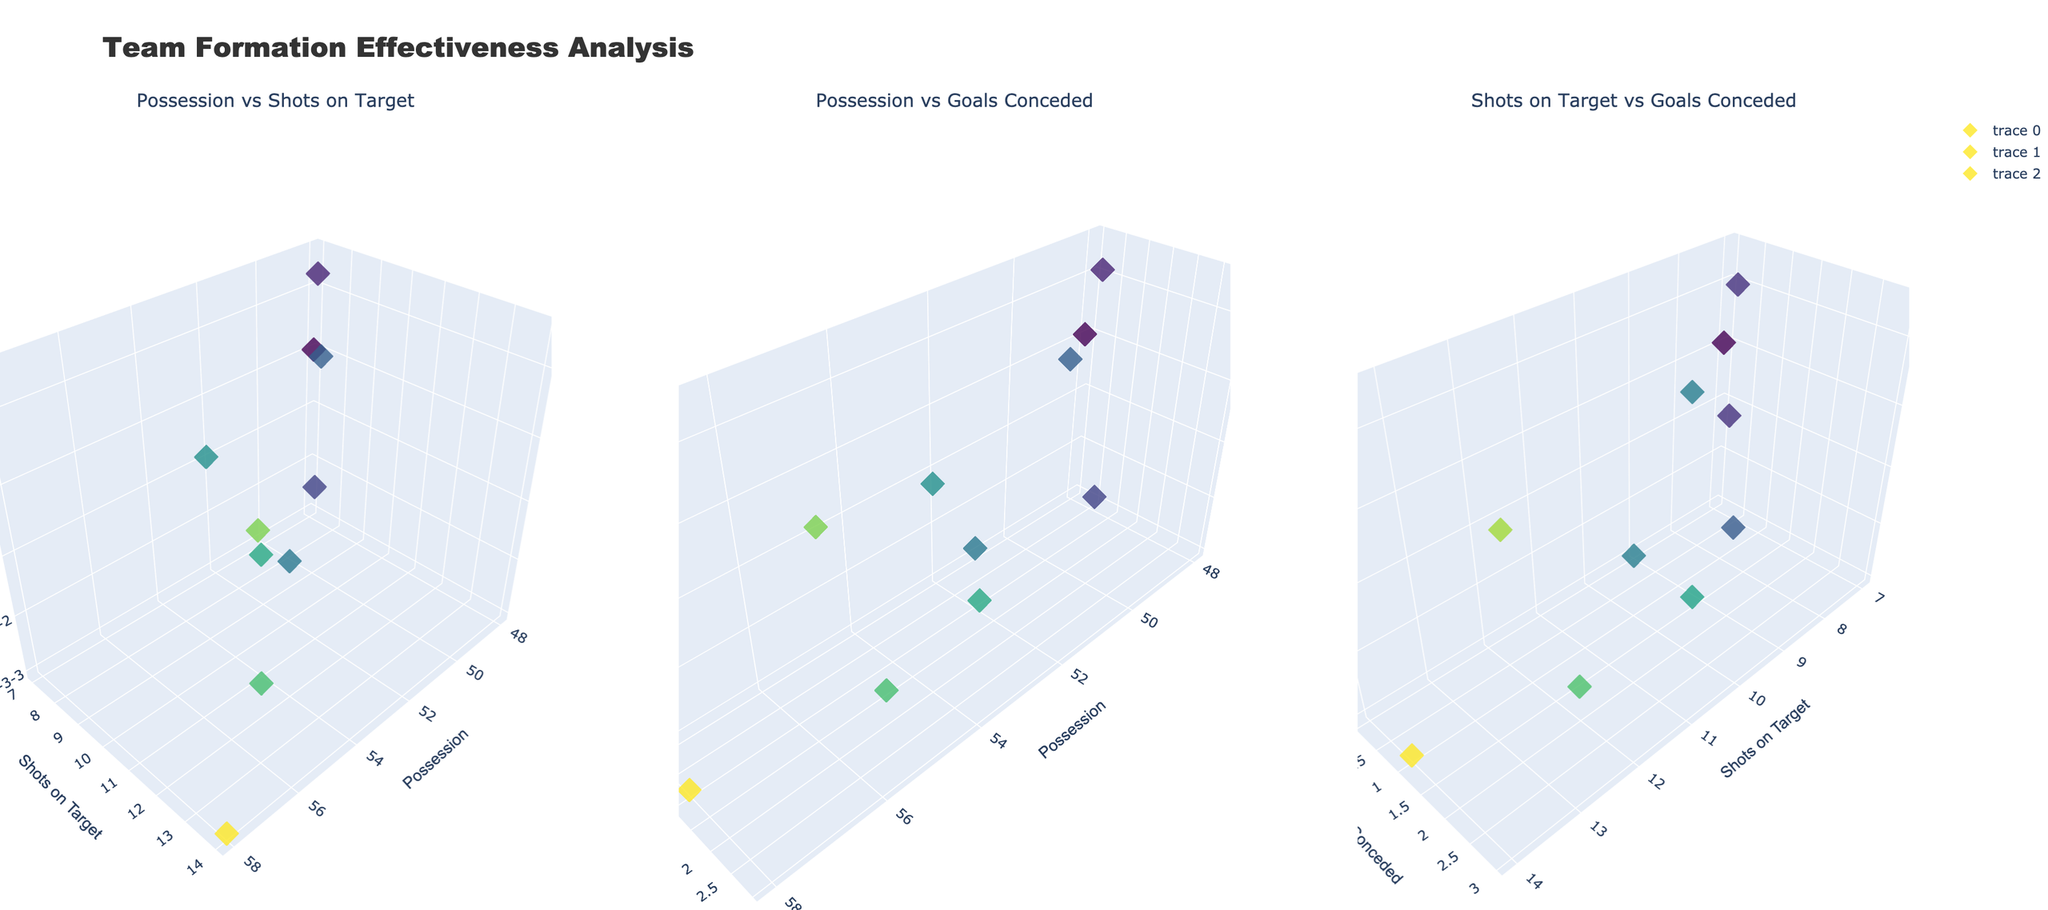Which formation has the highest possession percentage? Looking at the first subplot titled "Possession vs Shots on Target", identify the point on the x-axis with the highest value. The formation corresponding to this point has the highest possession.
Answer: 4-3-3 What’s the difference in possession between the 4-3-3 and 5-3-2 formations? The possession for 4-3-3 is 58% and for 5-3-2 is 48%. The difference is calculated as 58% - 48%.
Answer: 10% Which formation has the lowest number of shots on target? In the first subplot titled "Possession vs Shots on Target", find the point with the lowest value on the y-axis. Check the formation corresponding to this point.
Answer: 5-3-2 Which formation conceded the fewest goals? In the second subplot titled "Possession vs Goals Conceded", locate the point with the lowest value on the y-axis. The formation corresponding to this point conceded the fewest goals.
Answer: 5-3-2 What’s the average possession percentage among all formations? Sum all the possession values from the table and divide by the total number of formations, i.e., (58 + 55 + 52 + 50 + 54 + 53 + 48 + 56 + 51 + 49) / 10.
Answer: 52.6% How many formations have more than 10 shots on target? In the first subplot titled "Possession vs Shots on Target", count the points on the y-axis that have values greater than 10.
Answer: 4 In the "Possession vs Goals Conceded" subplot, do formations with higher possession generally concede more or fewer goals? By visually inspecting the second subplot, observe the trend of possession on the x-axis and goals conceded on the y-axis. Determine if higher possession correlates with higher or lower goals conceded.
Answer: Fewer goals Which formations show a balance between average possession and lower goals conceded in the second subplot? Identify formations in the "Possession vs Goals Conceded" subplot that fall in the middle of the possession range on the x-axis and have low values on the y-axis for goals conceded.
Answer: 4-1-4-1, 3-5-2 Is there a noticeable relationship between shots on target and goals conceded in the third subplot? Observe the third subplot "Shots on Target vs Goals Conceded", examining if an increase in the y-axis (shots on target) leads to an increase or decrease in the x-axis (goals conceded).
Answer: Weak relationship Which formations stand out as outliers in the third subplot for having high shots on target but relatively lower goals conceded? In the "Shots on Target vs Goals Conceded" subplot, identify formations where the y-axis (shots on target) is high while the x-axis (goals conceded) is relatively low.
Answer: 4-3-3, 4-3-2-1 